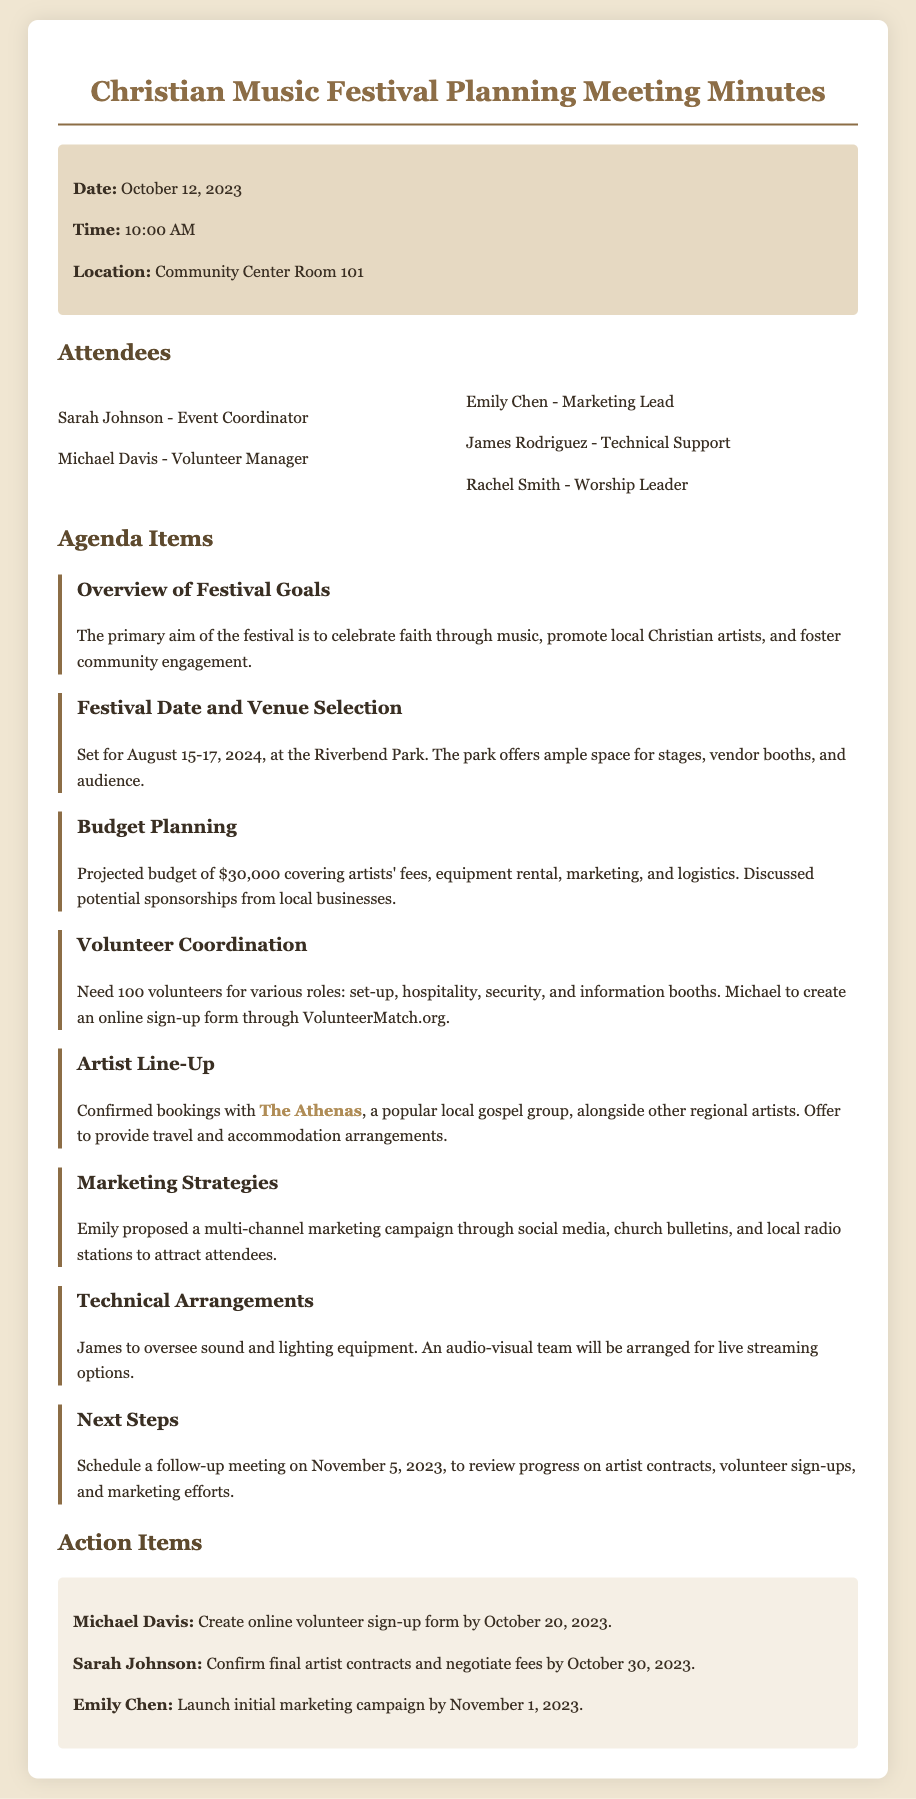What is the date of the meeting? The meeting is scheduled for October 12, 2023, as stated in the meeting info section.
Answer: October 12, 2023 Who is the Event Coordinator? The name of the Event Coordinator, as listed under attendees, is Sarah Johnson.
Answer: Sarah Johnson What is the projected budget for the festival? The budget planning agenda item mentions a projected budget of $30,000.
Answer: $30,000 What roles are needed for volunteers? The document indicates that volunteers are needed for set-up, hospitality, security, and information booths.
Answer: Set-up, hospitality, security, and information booths When is the next follow-up meeting scheduled? A follow-up meeting is scheduled for November 5, 2023, according to the next steps section.
Answer: November 5, 2023 What is the primary aim of the festival? The overview of festival goals states that the primary aim is to celebrate faith through music, promote local Christian artists, and foster community engagement.
Answer: Celebrate faith through music Who is managing the volunteers? Michael Davis is identified as the Volunteer Manager in the attendees section.
Answer: Michael Davis Who confirmed the bookings for the artist line-up? The document does not specify a person's name for this task, but it confirms bookings with The Athenas and other regional artists.
Answer: The Athenas What marketing strategy was proposed by Emily? Emily proposed a multi-channel marketing campaign through social media, church bulletins, and local radio stations to attract attendees.
Answer: Multi-channel marketing campaign 